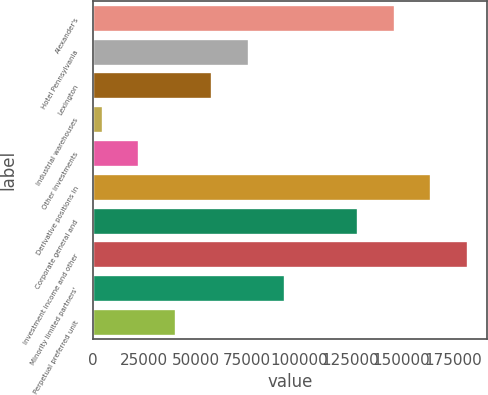Convert chart. <chart><loc_0><loc_0><loc_500><loc_500><bar_chart><fcel>Alexander's<fcel>Hotel Pennsylvania<fcel>Lexington<fcel>Industrial warehouses<fcel>Other investments<fcel>Derivative positions in<fcel>Corporate general and<fcel>Investment income and other<fcel>Minority limited partners'<fcel>Perpetual preferred unit<nl><fcel>146737<fcel>75809<fcel>58077<fcel>4881<fcel>22613<fcel>164469<fcel>129005<fcel>182201<fcel>93541<fcel>40345<nl></chart> 